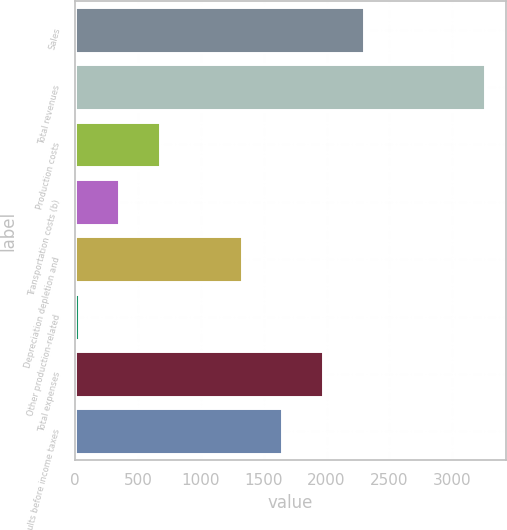<chart> <loc_0><loc_0><loc_500><loc_500><bar_chart><fcel>Sales<fcel>Total revenues<fcel>Production costs<fcel>Transportation costs (b)<fcel>Depreciation depletion and<fcel>Other production-related<fcel>Total expenses<fcel>Results before income taxes<nl><fcel>2295<fcel>3262<fcel>678<fcel>351.4<fcel>1324.8<fcel>28<fcel>1971.6<fcel>1648.2<nl></chart> 